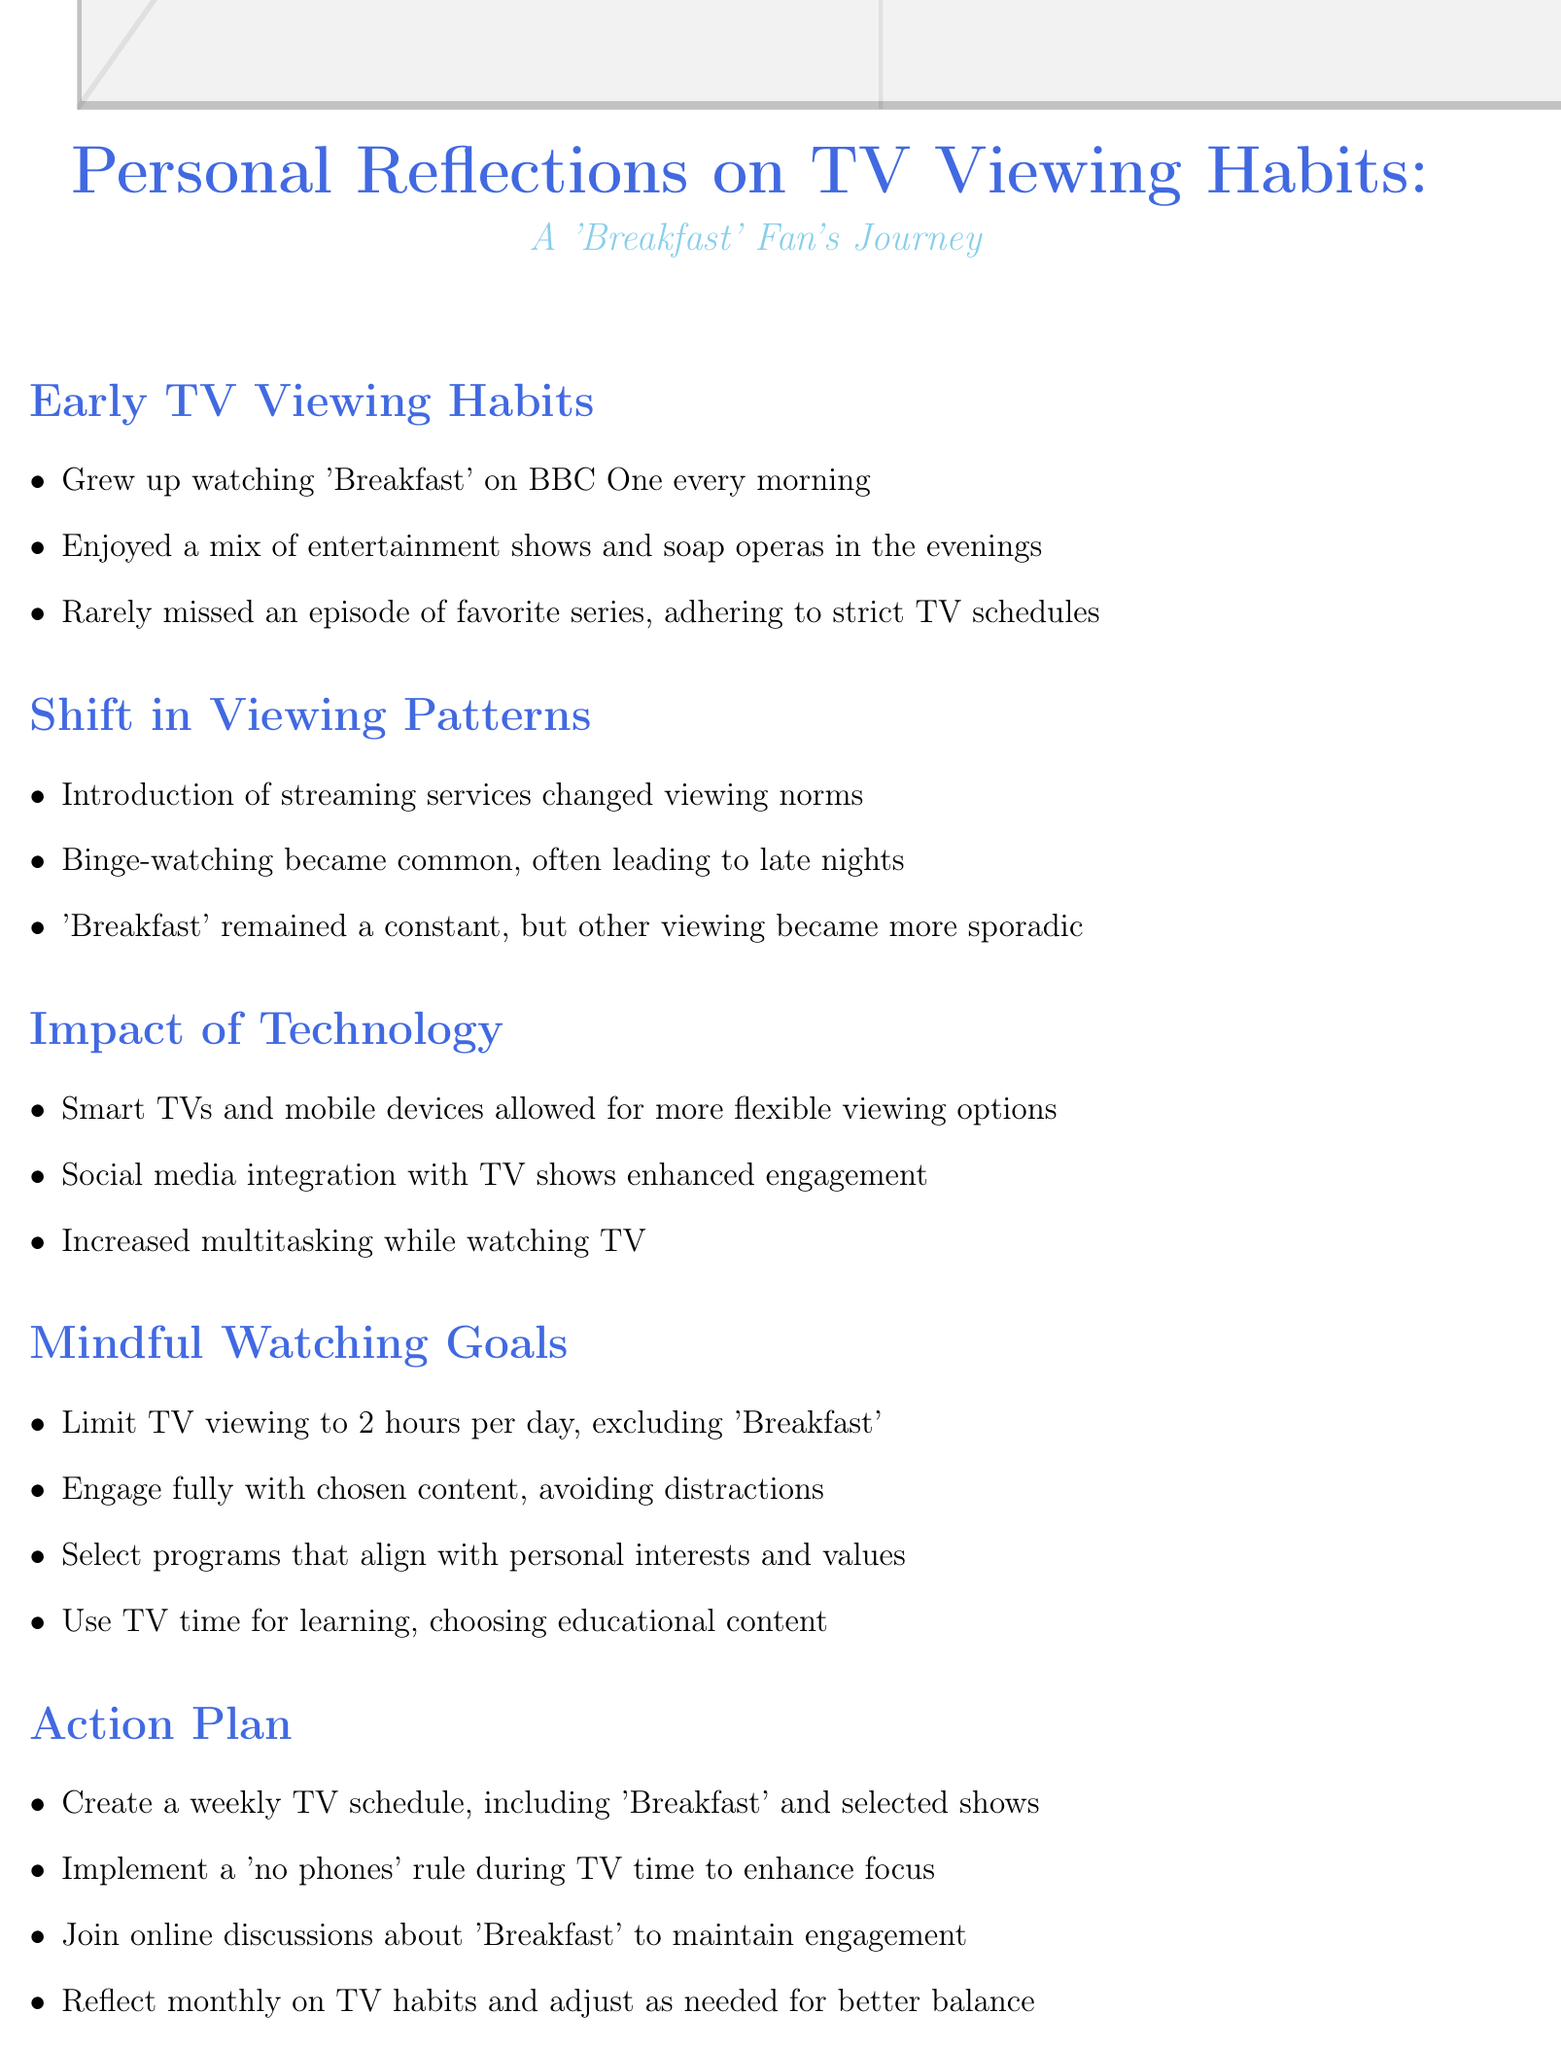What morning show did the author grow up watching? The author grew up watching 'Breakfast' on BBC One every morning.
Answer: 'Breakfast' What was one consequence of binge-watching mentioned? Binge-watching became common, often leading to late nights and disrupted sleep.
Answer: Late nights How many hours a day does the author intend to limit their TV viewing to? The author aims to limit TV viewing to 2 hours per day, excluding 'Breakfast'.
Answer: 2 hours What is the author's rule during TV time to enhance focus? The author plans to implement a 'no phones' rule during TV time to enhance focus.
Answer: No phones What type of content does the author aim to choose for learning? The author aims to use TV time for learning, choosing documentaries and educational content.
Answer: Documentaries and educational content What does the author engage in to maintain community involvement regarding 'Breakfast'? The author plans to join online discussions about 'Breakfast' to maintain community engagement.
Answer: Online discussions Which technological advancement allowed more flexible viewing options? Smart TVs and mobile devices allowed for more flexible viewing options.
Answer: Smart TVs and mobile devices What has the introduction of streaming services changed? The introduction of streaming services like Netflix and iPlayer changed viewing norms.
Answer: Viewing norms 